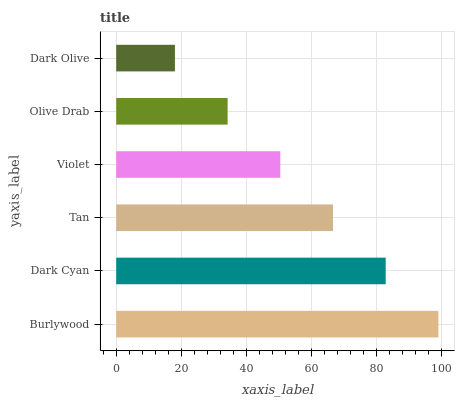Is Dark Olive the minimum?
Answer yes or no. Yes. Is Burlywood the maximum?
Answer yes or no. Yes. Is Dark Cyan the minimum?
Answer yes or no. No. Is Dark Cyan the maximum?
Answer yes or no. No. Is Burlywood greater than Dark Cyan?
Answer yes or no. Yes. Is Dark Cyan less than Burlywood?
Answer yes or no. Yes. Is Dark Cyan greater than Burlywood?
Answer yes or no. No. Is Burlywood less than Dark Cyan?
Answer yes or no. No. Is Tan the high median?
Answer yes or no. Yes. Is Violet the low median?
Answer yes or no. Yes. Is Violet the high median?
Answer yes or no. No. Is Burlywood the low median?
Answer yes or no. No. 